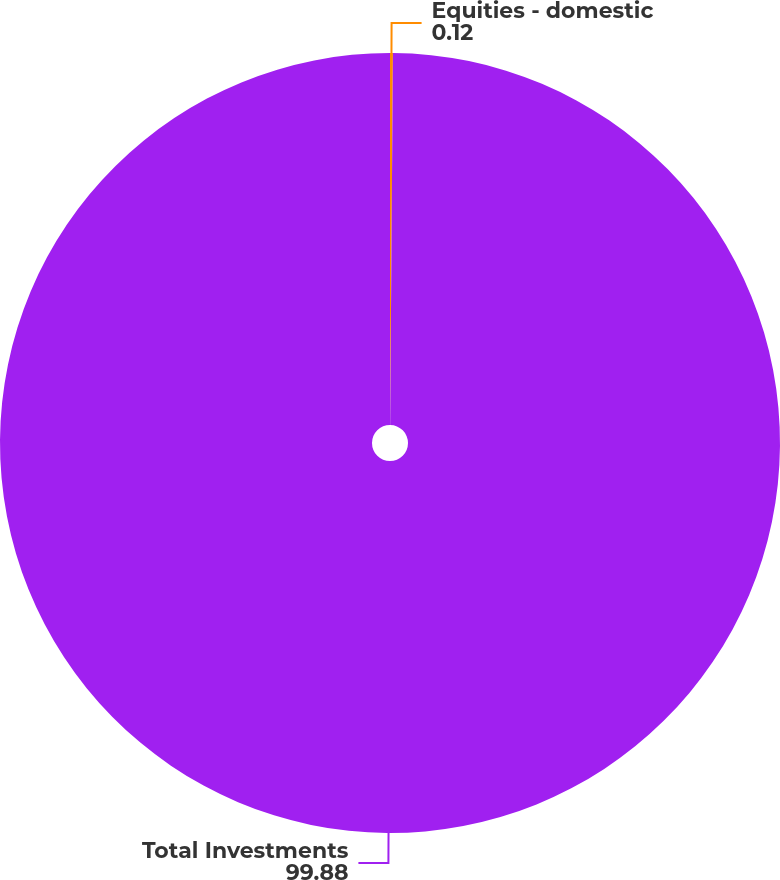Convert chart. <chart><loc_0><loc_0><loc_500><loc_500><pie_chart><fcel>Equities - domestic<fcel>Total Investments<nl><fcel>0.12%<fcel>99.88%<nl></chart> 